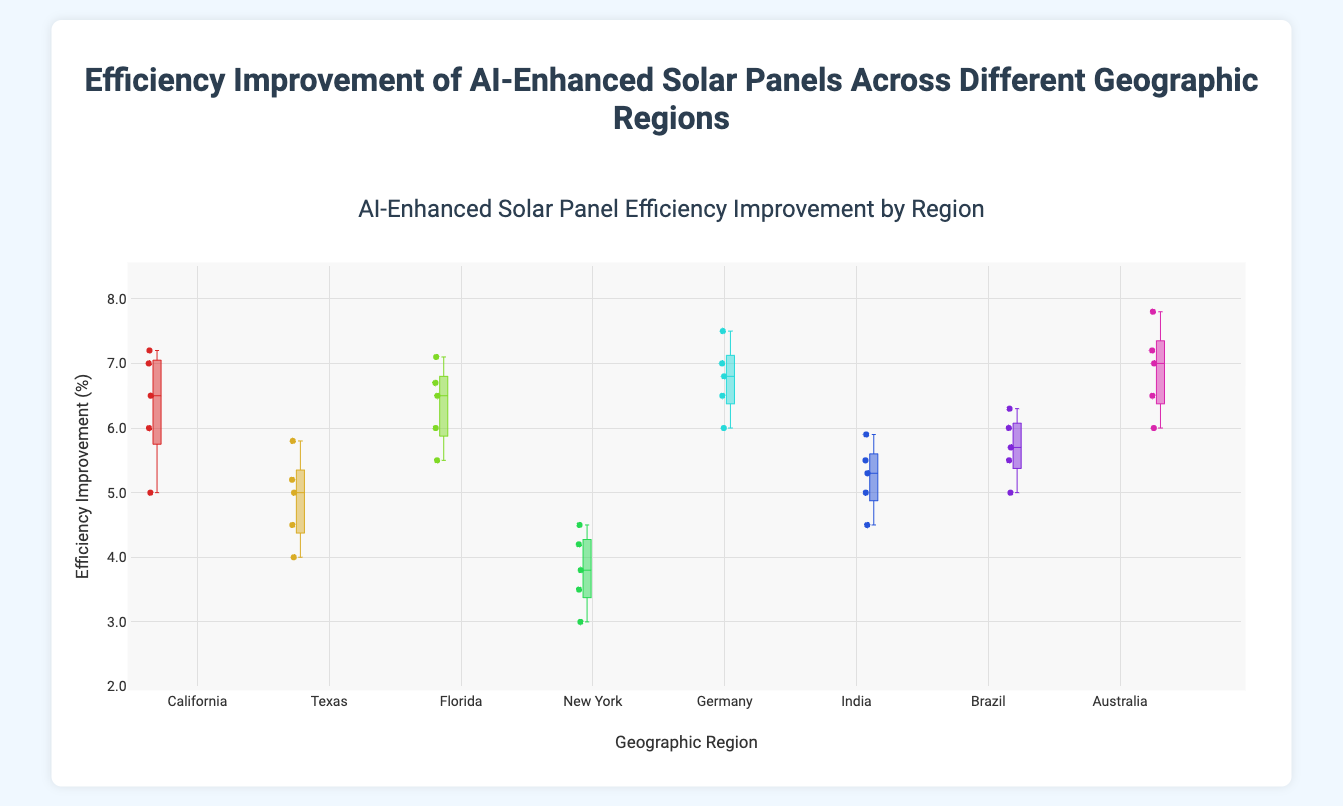Which region has the highest median efficiency improvement? The box plot's median is depicted by the line inside the box; for each region, locate this line's highest position.
Answer: Australia Which region has the lowest median efficiency improvement? Look for the region whose median line is the lowest on the y-axis.
Answer: New York What is the range of efficiency improvement in Texas? The range is determined by the difference between the maximum and minimum values (whiskers) of the Texas box plot.
Answer: 4 to 5.8 Which regions have a median efficiency improvement value above 6%? Identify the regions where the median line falls above the 6% mark on the y-axis.
Answer: California, Florida, Germany, Australia Which geographic region shows the greatest variability in efficiency improvements? Variability can be assessed by the interquartile range (IQR), which is the height of the box in each plot. Identify the region with the tallest box.
Answer: California How does the efficiency improvement in Germany compare to California? Compare the positions of the median, interquartile range (IQR), and whiskers of both box plots.
Answer: Germany has a slightly higher median and a narrower IQR than California What is the interquartile range (IQR) for New York? The IQR is the range within the box, from the 25th percentile to the 75th percentile.
Answer: 3.5 to 4.2 Which regions have outlier points, assuming the plot shows all data points? Look for regions where individual points lie outside the whiskers of the box plot.
Answer: None What is the average median efficiency improvement across all regions? Sum the median values of all regions and divide by the number of regions. Medians: 6.5 (California), 5 (Texas), 6.5 (Florida), 3.8 (New York), 6.8 (Germany), 5.3 (India), 5.7 (Brazil), 7.2 (Australia). Average median = (6.5+5+6.5+3.8+6.8+5.3+5.7+7.2)/8 = 5.85
Answer: 5.85 Which region has the smallest interquartile range? Identify the region with the shortest box on the plot, representing the smallest IQR.
Answer: Brazil 